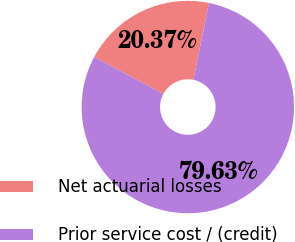<chart> <loc_0><loc_0><loc_500><loc_500><pie_chart><fcel>Net actuarial losses<fcel>Prior service cost / (credit)<nl><fcel>20.37%<fcel>79.63%<nl></chart> 